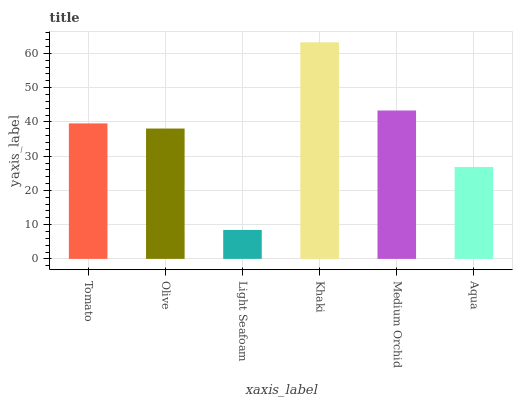Is Light Seafoam the minimum?
Answer yes or no. Yes. Is Khaki the maximum?
Answer yes or no. Yes. Is Olive the minimum?
Answer yes or no. No. Is Olive the maximum?
Answer yes or no. No. Is Tomato greater than Olive?
Answer yes or no. Yes. Is Olive less than Tomato?
Answer yes or no. Yes. Is Olive greater than Tomato?
Answer yes or no. No. Is Tomato less than Olive?
Answer yes or no. No. Is Tomato the high median?
Answer yes or no. Yes. Is Olive the low median?
Answer yes or no. Yes. Is Aqua the high median?
Answer yes or no. No. Is Aqua the low median?
Answer yes or no. No. 